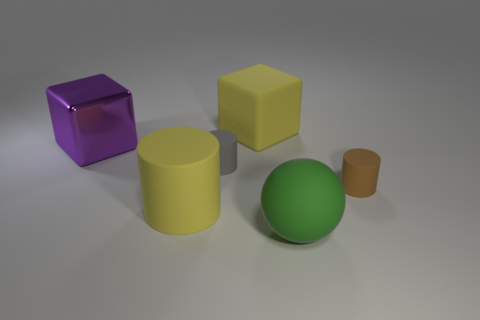Add 3 tiny matte things. How many objects exist? 9 Subtract all cubes. How many objects are left? 4 Add 4 tiny brown rubber objects. How many tiny brown rubber objects exist? 5 Subtract 1 gray cylinders. How many objects are left? 5 Subtract all big spheres. Subtract all balls. How many objects are left? 4 Add 2 large cubes. How many large cubes are left? 4 